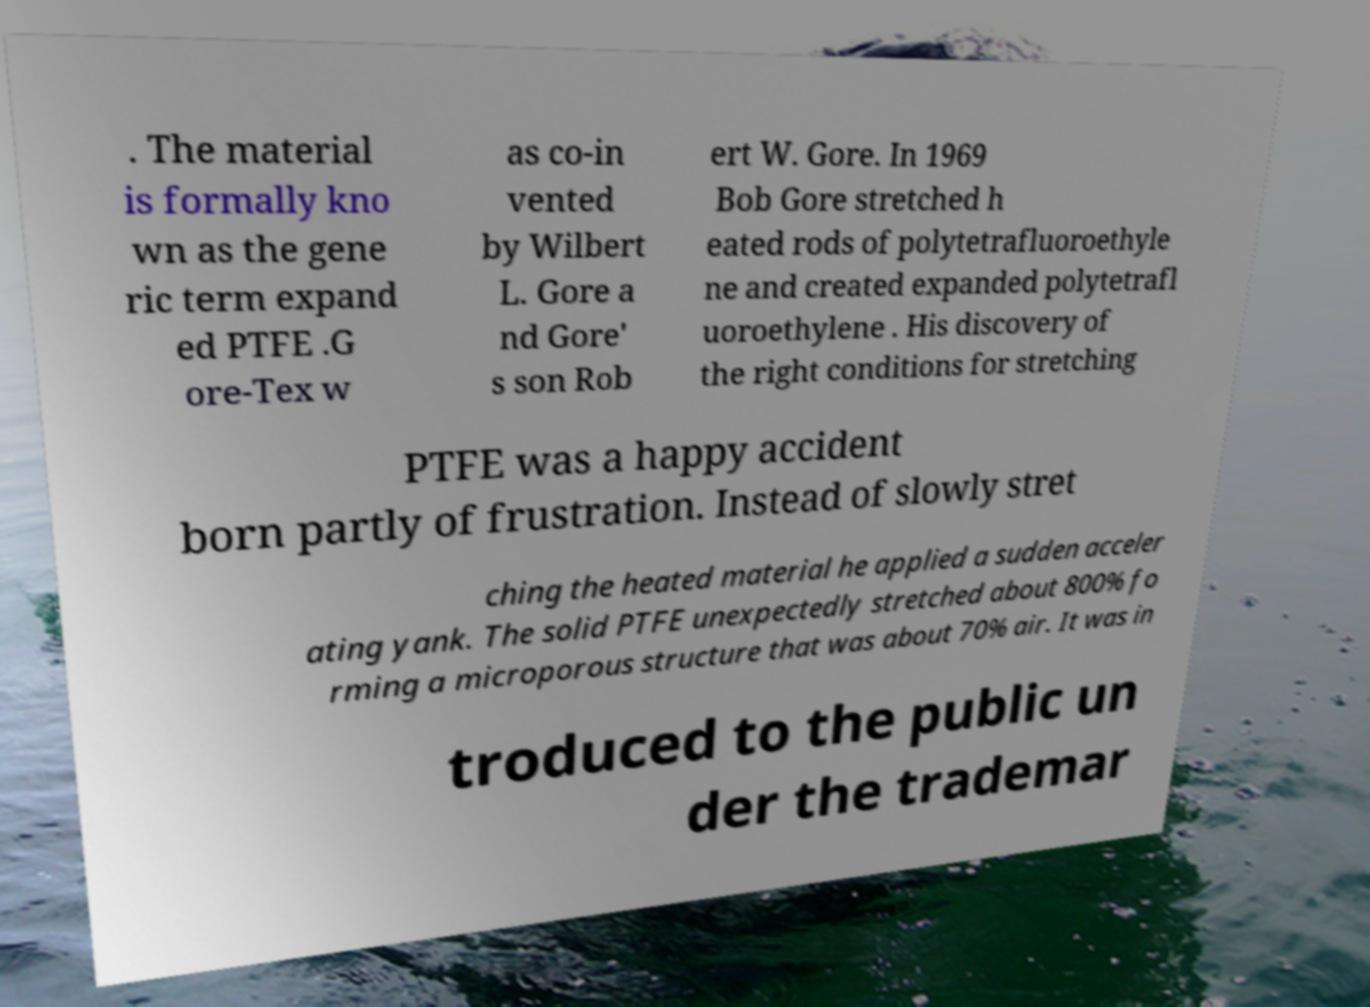Can you read and provide the text displayed in the image?This photo seems to have some interesting text. Can you extract and type it out for me? . The material is formally kno wn as the gene ric term expand ed PTFE .G ore-Tex w as co-in vented by Wilbert L. Gore a nd Gore' s son Rob ert W. Gore. In 1969 Bob Gore stretched h eated rods of polytetrafluoroethyle ne and created expanded polytetrafl uoroethylene . His discovery of the right conditions for stretching PTFE was a happy accident born partly of frustration. Instead of slowly stret ching the heated material he applied a sudden acceler ating yank. The solid PTFE unexpectedly stretched about 800% fo rming a microporous structure that was about 70% air. It was in troduced to the public un der the trademar 